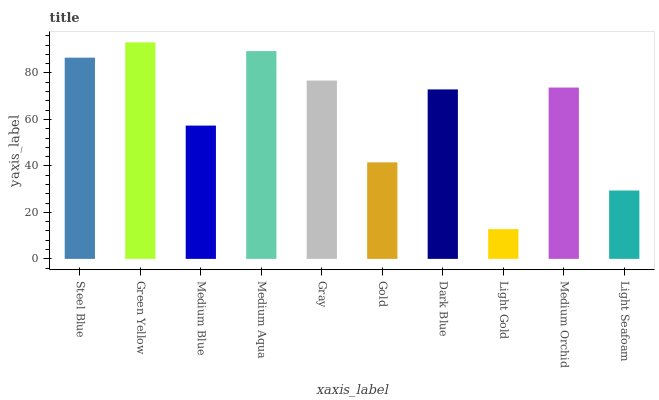Is Light Gold the minimum?
Answer yes or no. Yes. Is Green Yellow the maximum?
Answer yes or no. Yes. Is Medium Blue the minimum?
Answer yes or no. No. Is Medium Blue the maximum?
Answer yes or no. No. Is Green Yellow greater than Medium Blue?
Answer yes or no. Yes. Is Medium Blue less than Green Yellow?
Answer yes or no. Yes. Is Medium Blue greater than Green Yellow?
Answer yes or no. No. Is Green Yellow less than Medium Blue?
Answer yes or no. No. Is Medium Orchid the high median?
Answer yes or no. Yes. Is Dark Blue the low median?
Answer yes or no. Yes. Is Gray the high median?
Answer yes or no. No. Is Gray the low median?
Answer yes or no. No. 